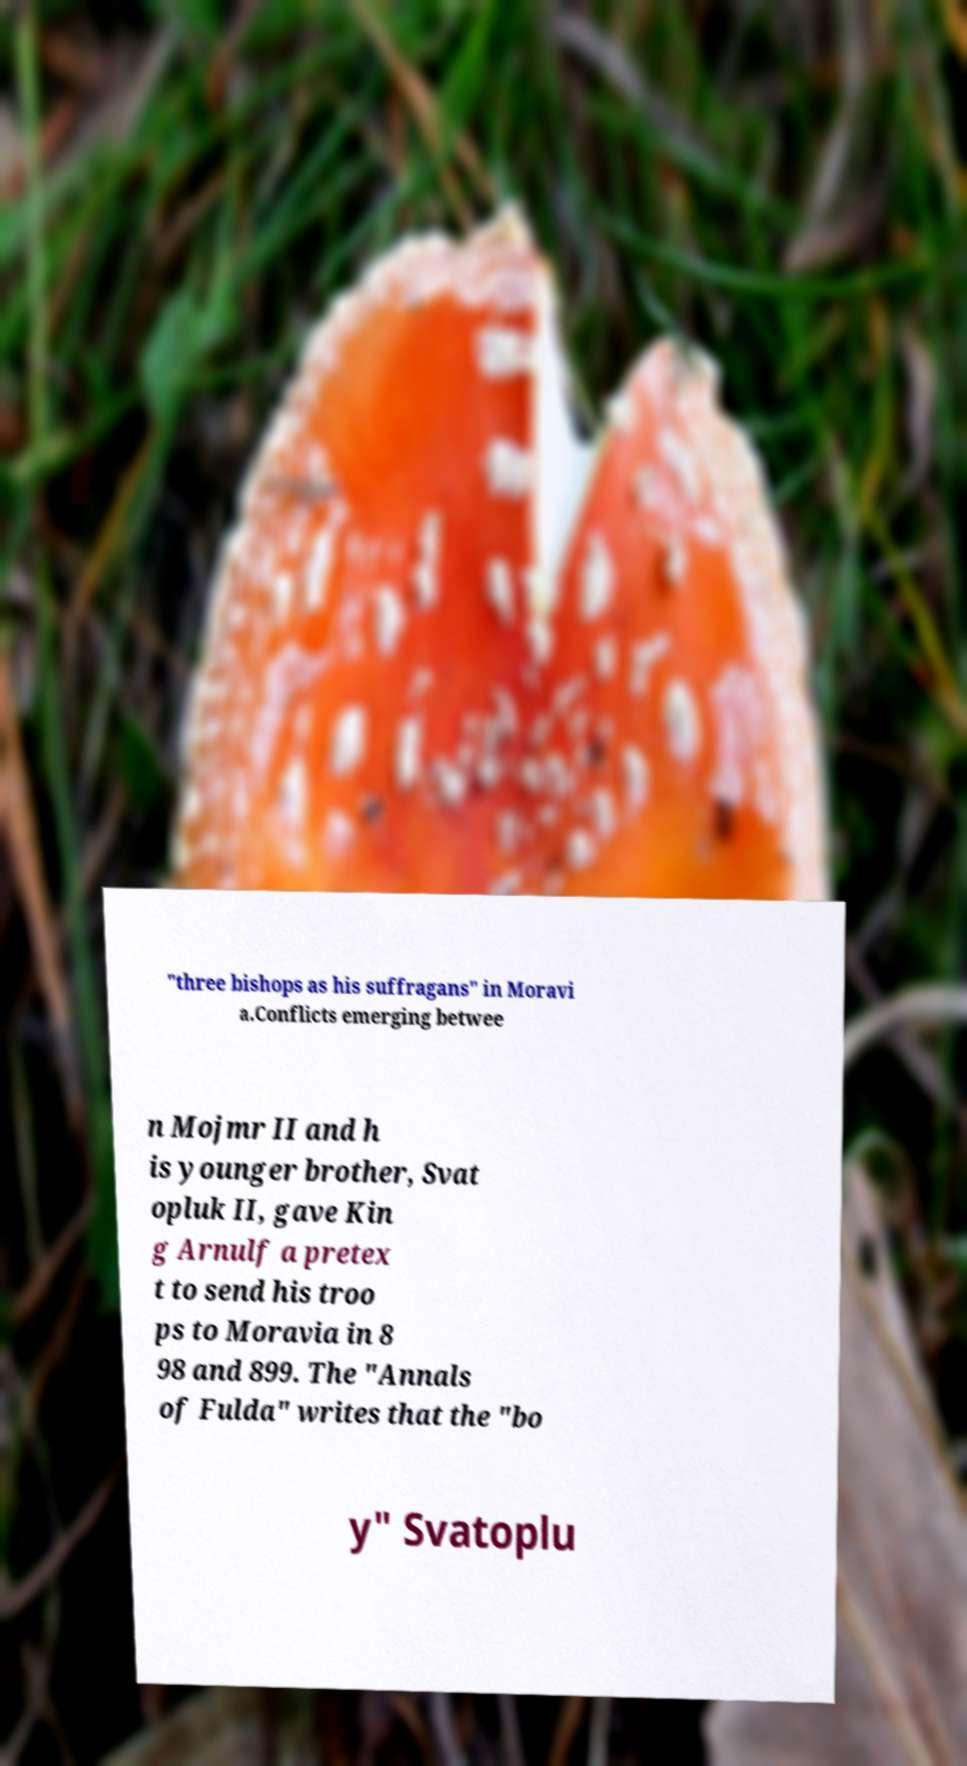For documentation purposes, I need the text within this image transcribed. Could you provide that? "three bishops as his suffragans" in Moravi a.Conflicts emerging betwee n Mojmr II and h is younger brother, Svat opluk II, gave Kin g Arnulf a pretex t to send his troo ps to Moravia in 8 98 and 899. The "Annals of Fulda" writes that the "bo y" Svatoplu 